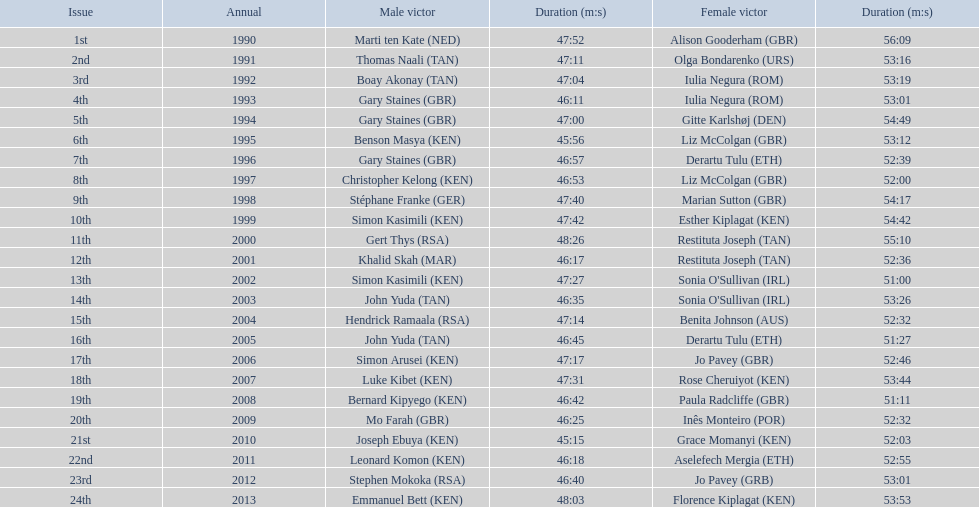What place did sonia o'sullivan finish in 2003? 14th. How long did it take her to finish? 53:26. 